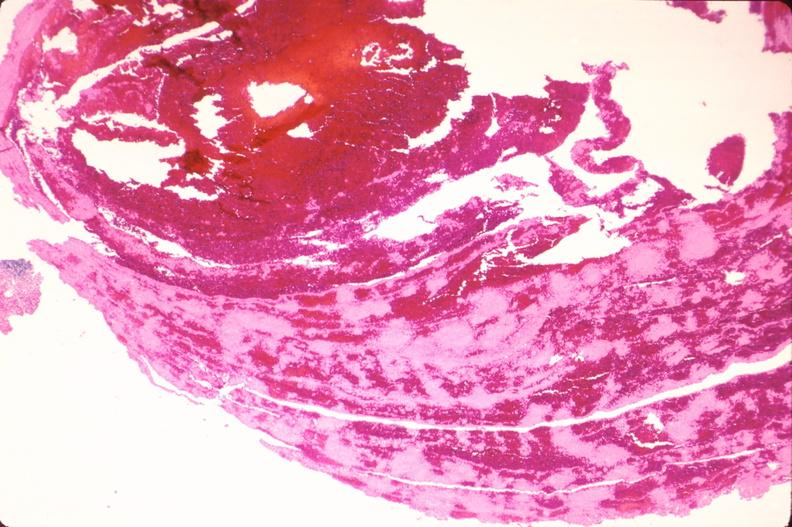what does this image show?
Answer the question using a single word or phrase. Thromboembolus from leg veins in pulmonary artery 